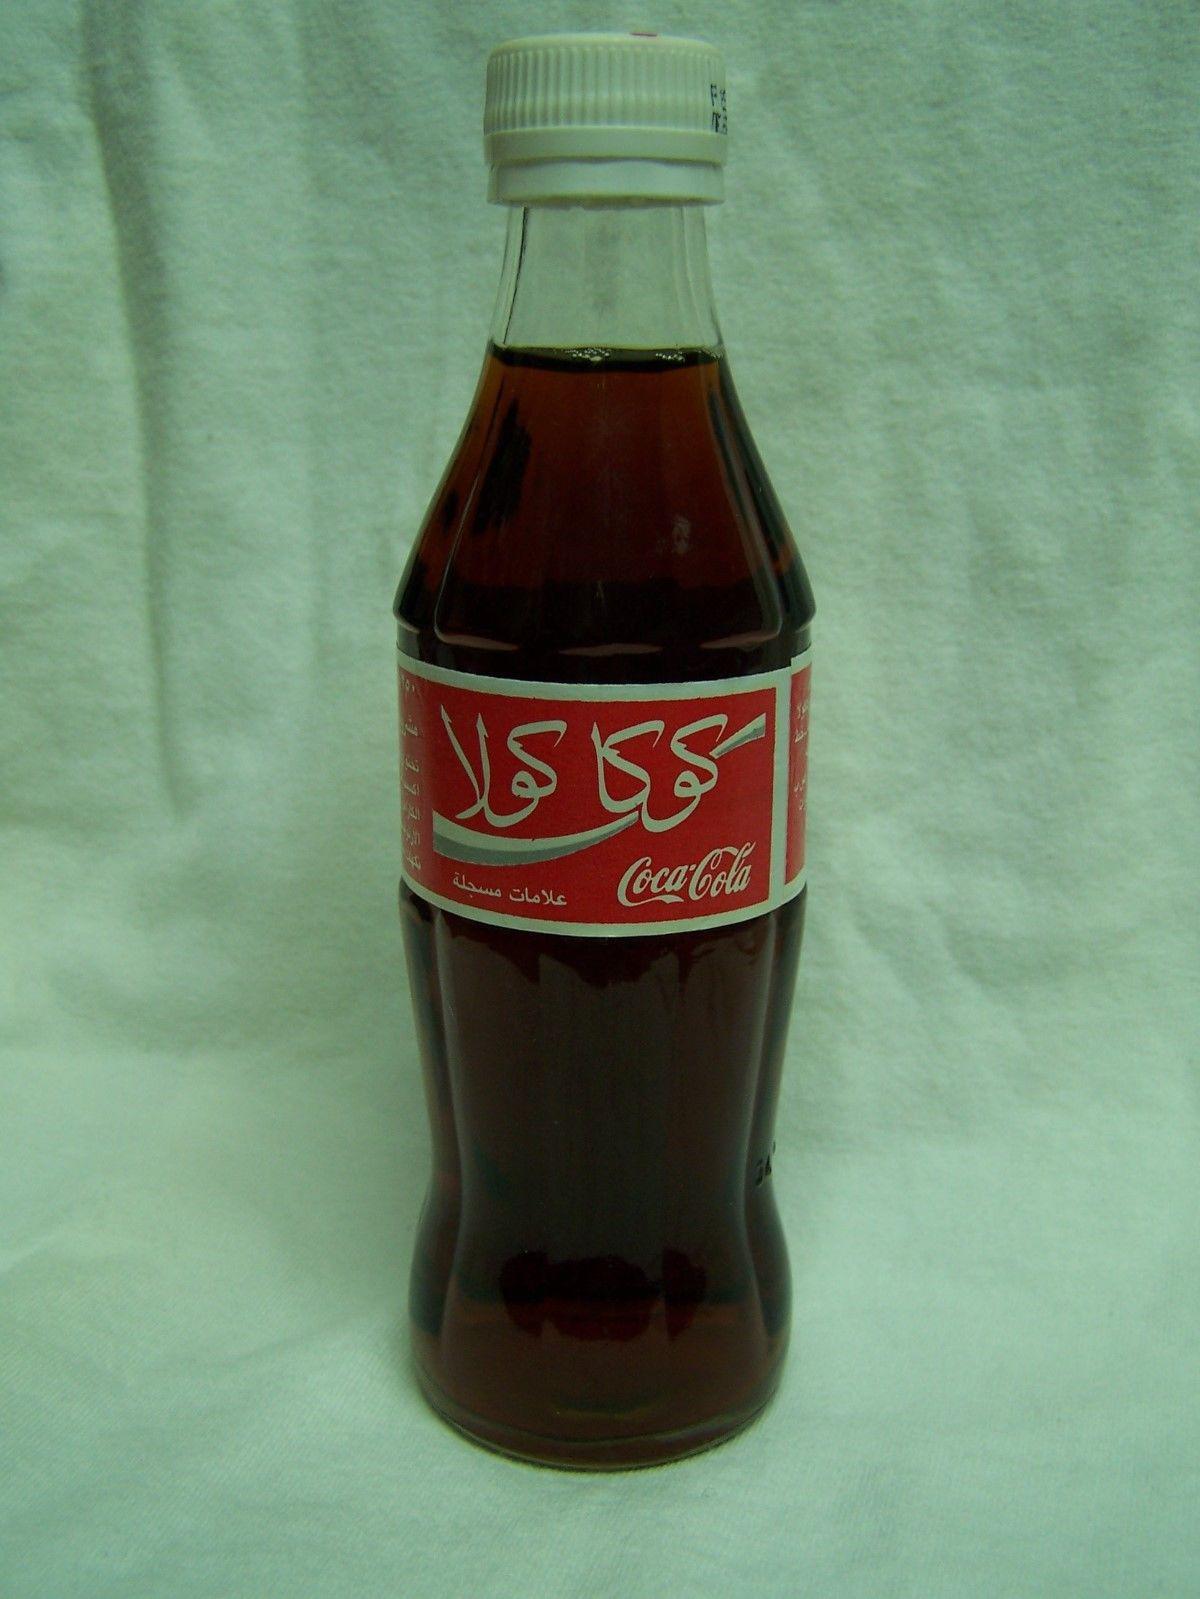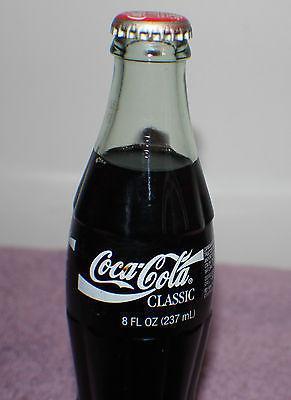The first image is the image on the left, the second image is the image on the right. Evaluate the accuracy of this statement regarding the images: "At least one soda bottle is written in a foreign language.". Is it true? Answer yes or no. Yes. The first image is the image on the left, the second image is the image on the right. Assess this claim about the two images: "The bottle in the left image has a partly red label.". Correct or not? Answer yes or no. Yes. 